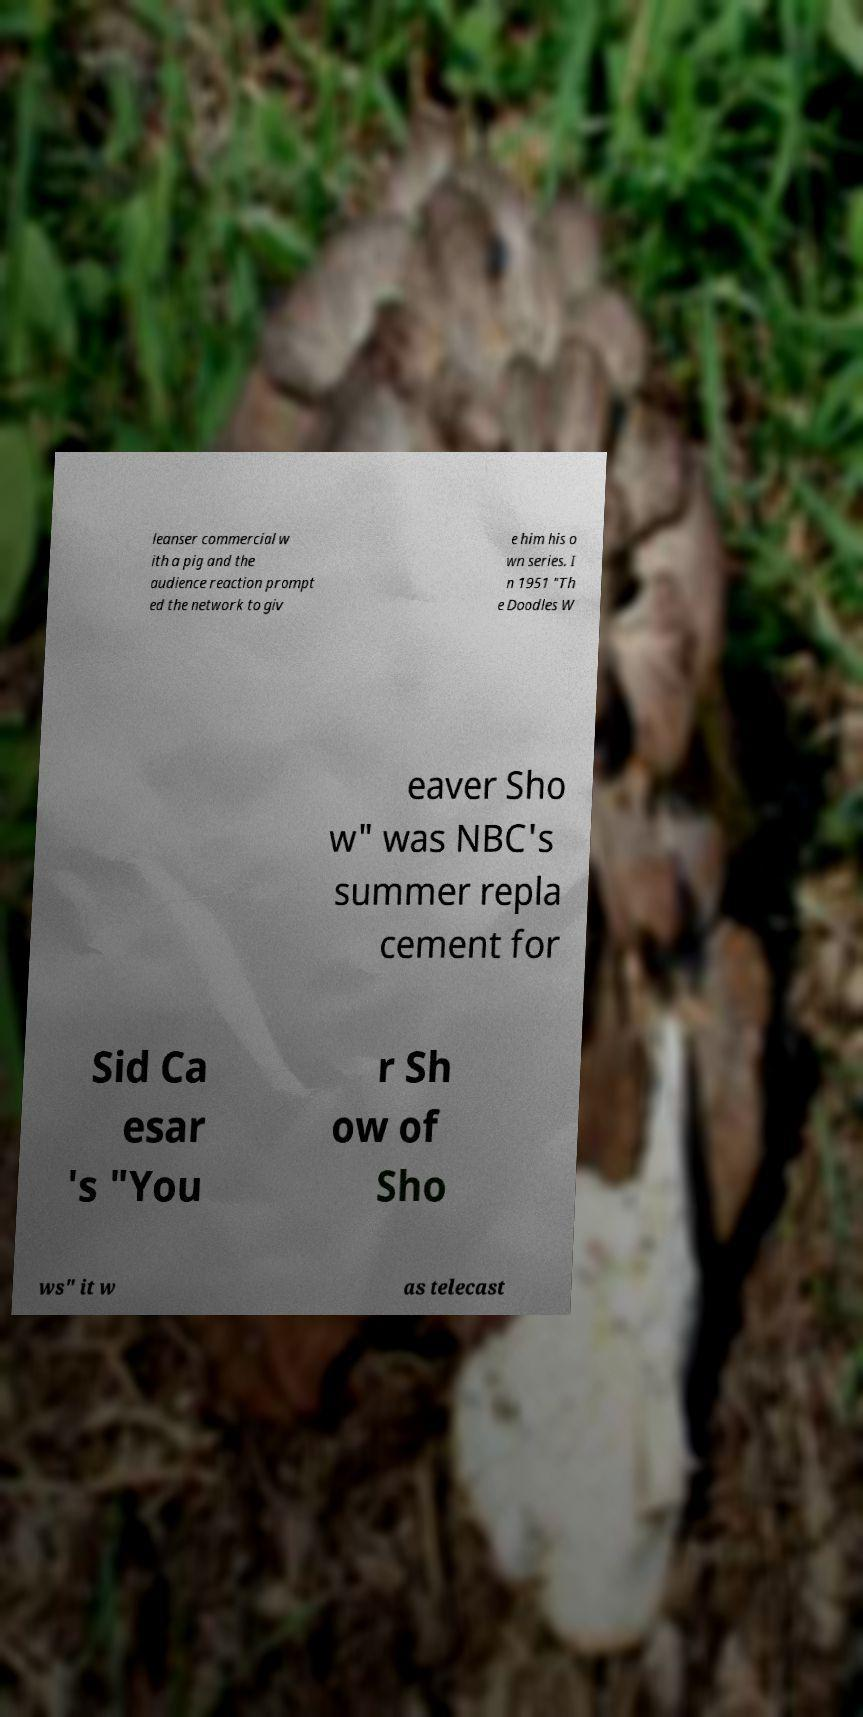I need the written content from this picture converted into text. Can you do that? leanser commercial w ith a pig and the audience reaction prompt ed the network to giv e him his o wn series. I n 1951 "Th e Doodles W eaver Sho w" was NBC's summer repla cement for Sid Ca esar 's "You r Sh ow of Sho ws" it w as telecast 